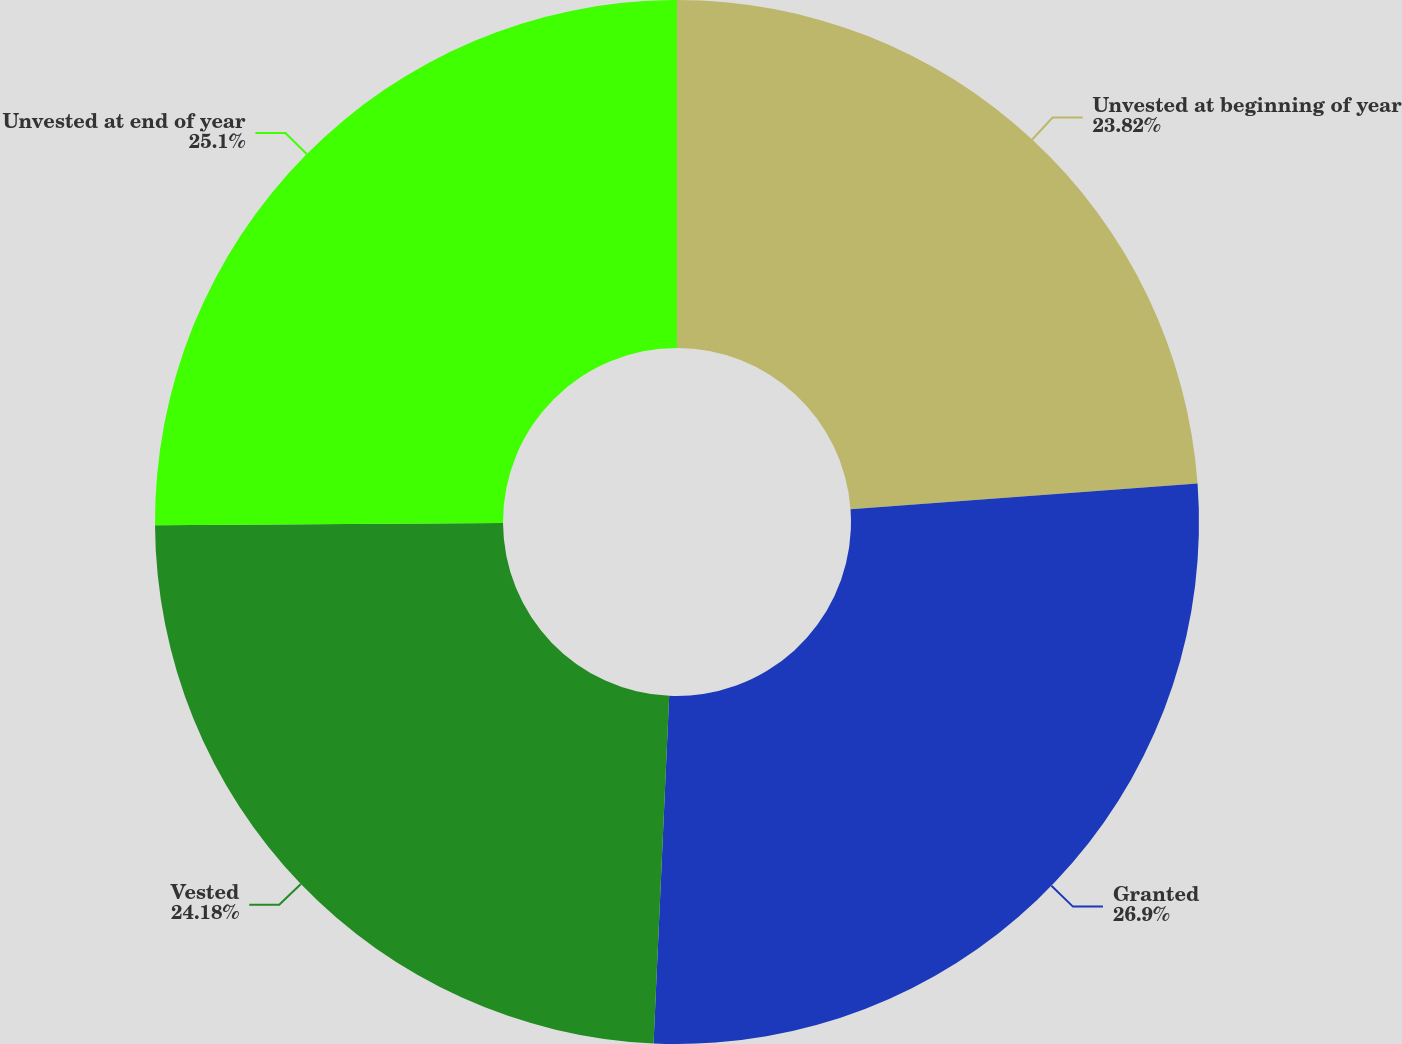Convert chart. <chart><loc_0><loc_0><loc_500><loc_500><pie_chart><fcel>Unvested at beginning of year<fcel>Granted<fcel>Vested<fcel>Unvested at end of year<nl><fcel>23.82%<fcel>26.89%<fcel>24.18%<fcel>25.1%<nl></chart> 